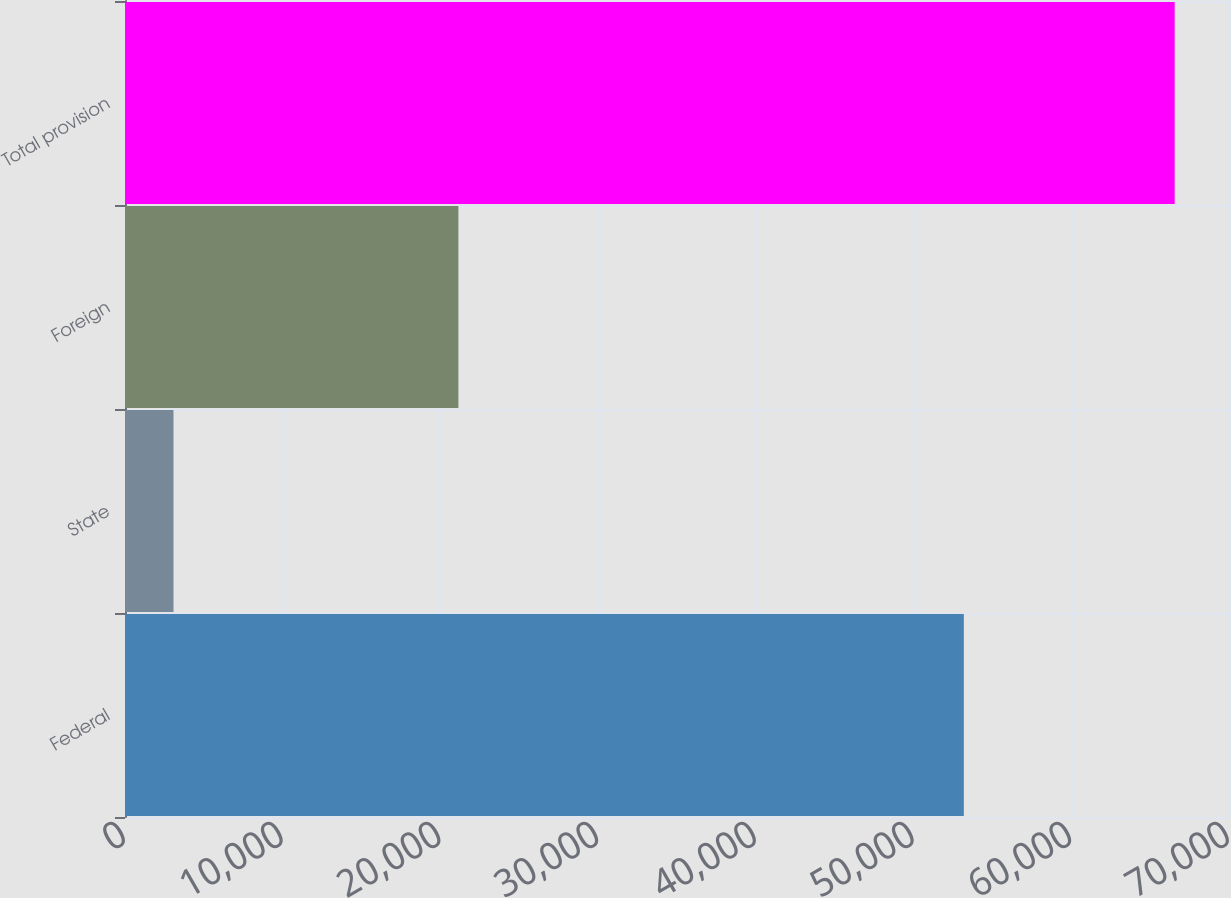Convert chart to OTSL. <chart><loc_0><loc_0><loc_500><loc_500><bar_chart><fcel>Federal<fcel>State<fcel>Foreign<fcel>Total provision<nl><fcel>53187<fcel>3075<fcel>21138<fcel>66556<nl></chart> 